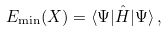Convert formula to latex. <formula><loc_0><loc_0><loc_500><loc_500>E _ { \min } ( X ) = \langle \Psi | \hat { H } | \Psi \rangle \, ,</formula> 